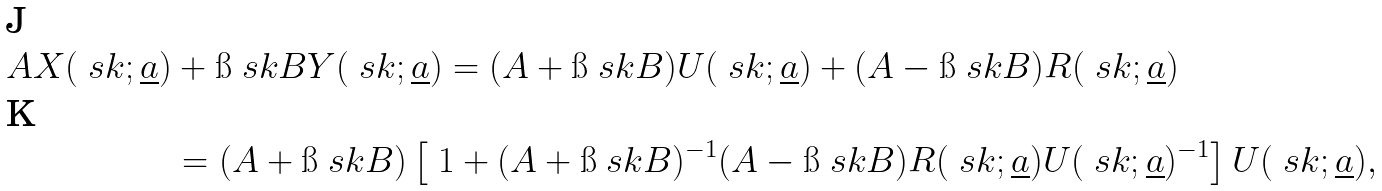<formula> <loc_0><loc_0><loc_500><loc_500>A X ( \ s k ; \underline { a } ) & + \i \ s k B Y ( \ s k ; \underline { a } ) = ( A + \i \ s k B ) U ( \ s k ; \underline { a } ) + ( A - \i \ s k B ) R ( \ s k ; \underline { a } ) \\ & = ( A + \i \ s k B ) \left [ \ 1 + ( A + \i \ s k B ) ^ { - 1 } ( A - \i \ s k B ) R ( \ s k ; \underline { a } ) U ( \ s k ; \underline { a } ) ^ { - 1 } \right ] U ( \ s k ; \underline { a } ) ,</formula> 